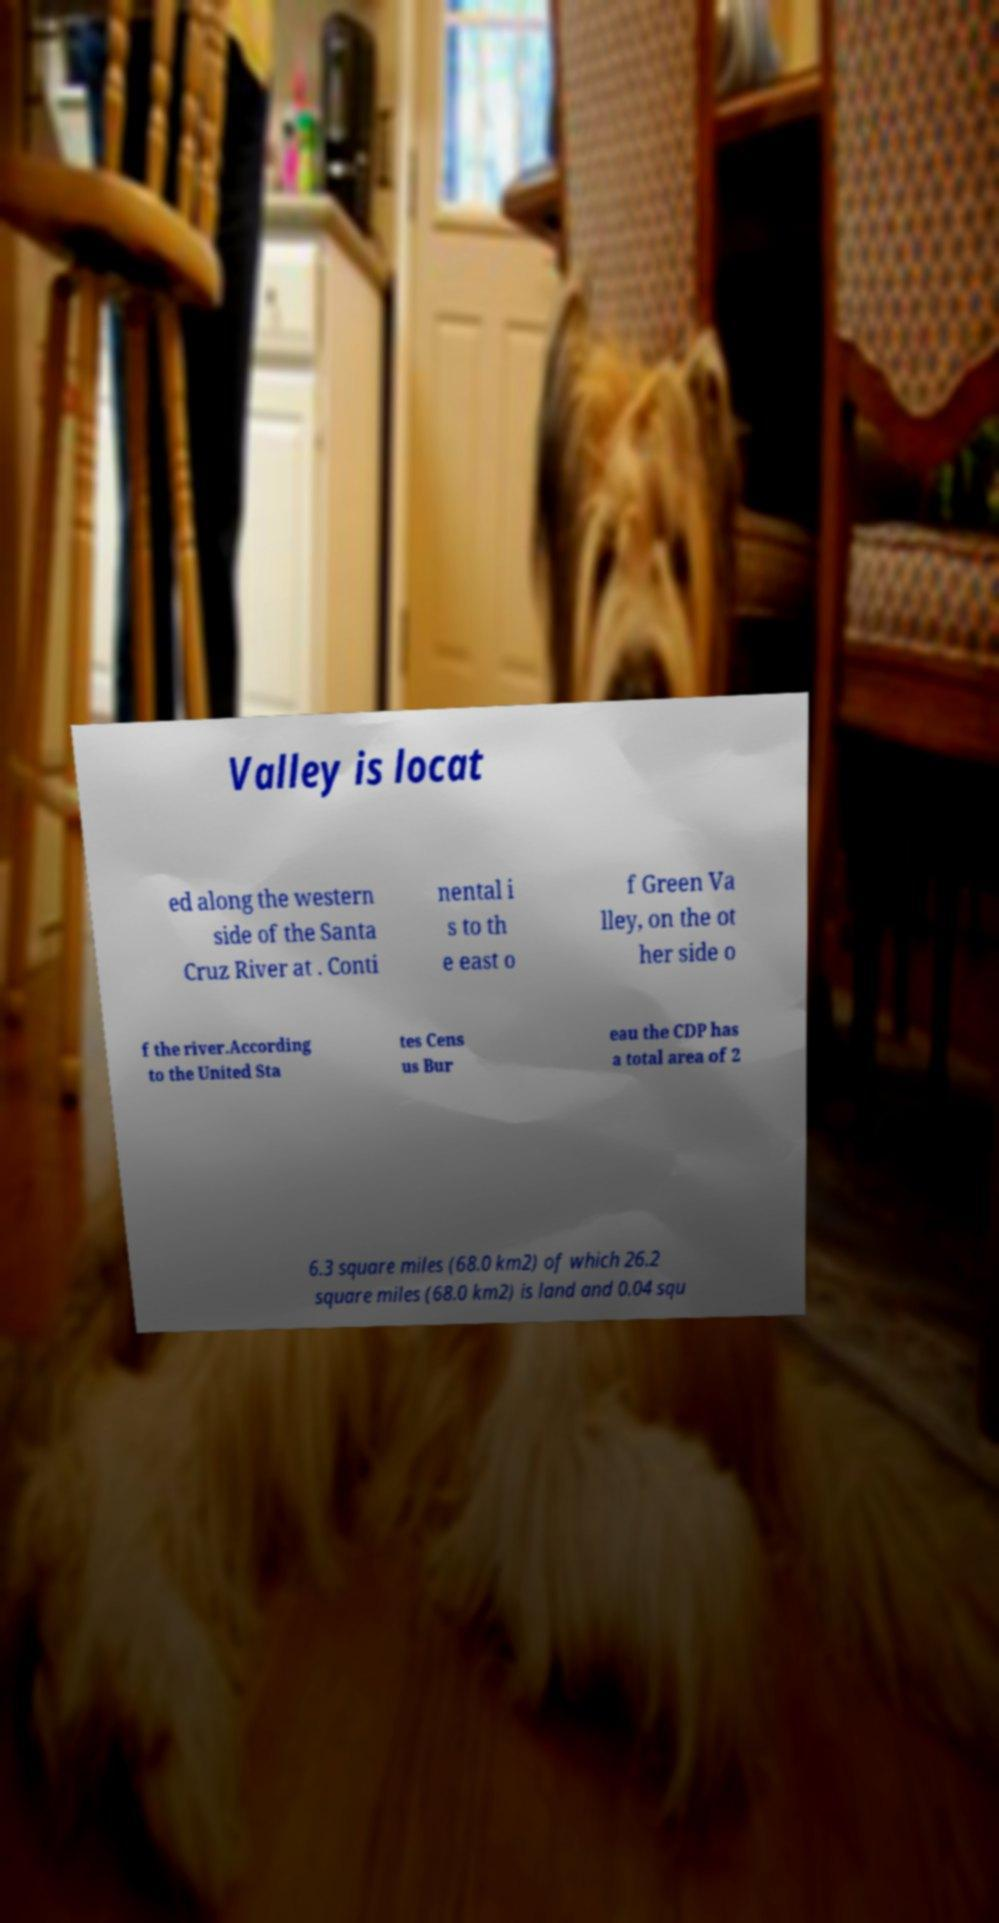Can you read and provide the text displayed in the image?This photo seems to have some interesting text. Can you extract and type it out for me? Valley is locat ed along the western side of the Santa Cruz River at . Conti nental i s to th e east o f Green Va lley, on the ot her side o f the river.According to the United Sta tes Cens us Bur eau the CDP has a total area of 2 6.3 square miles (68.0 km2) of which 26.2 square miles (68.0 km2) is land and 0.04 squ 